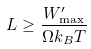Convert formula to latex. <formula><loc_0><loc_0><loc_500><loc_500>L \geq \frac { W _ { \max } ^ { \prime } } { \Omega k _ { B } T }</formula> 